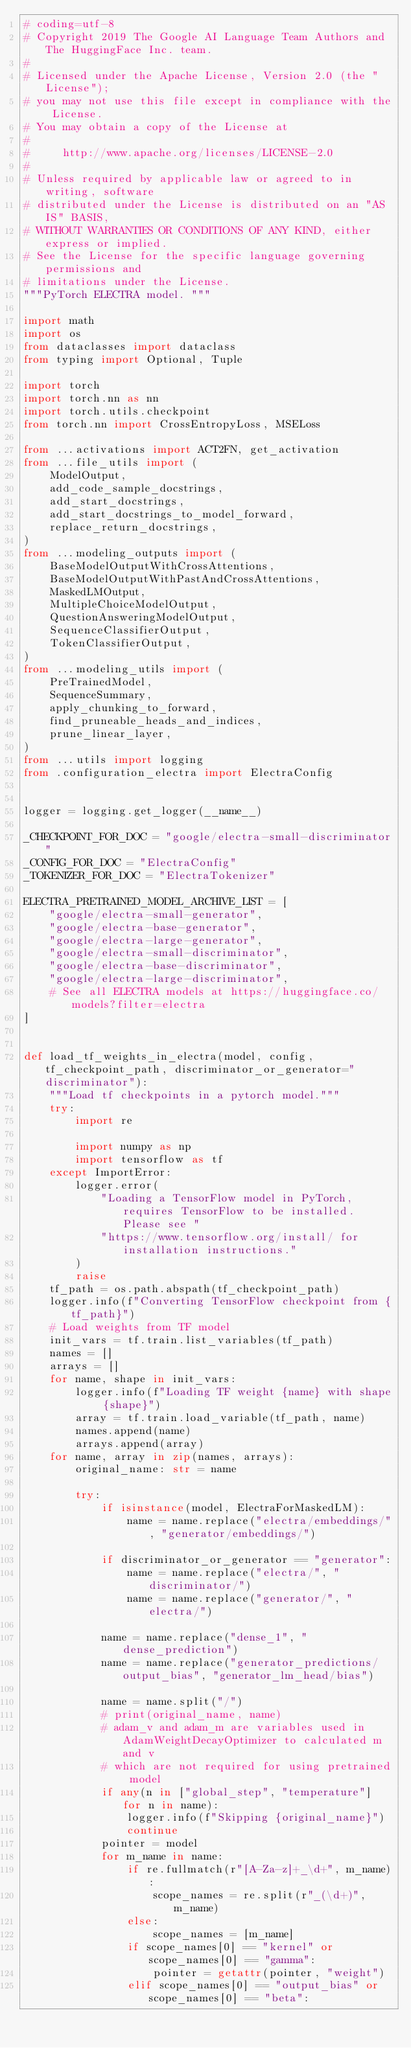Convert code to text. <code><loc_0><loc_0><loc_500><loc_500><_Python_># coding=utf-8
# Copyright 2019 The Google AI Language Team Authors and The HuggingFace Inc. team.
#
# Licensed under the Apache License, Version 2.0 (the "License");
# you may not use this file except in compliance with the License.
# You may obtain a copy of the License at
#
#     http://www.apache.org/licenses/LICENSE-2.0
#
# Unless required by applicable law or agreed to in writing, software
# distributed under the License is distributed on an "AS IS" BASIS,
# WITHOUT WARRANTIES OR CONDITIONS OF ANY KIND, either express or implied.
# See the License for the specific language governing permissions and
# limitations under the License.
"""PyTorch ELECTRA model. """

import math
import os
from dataclasses import dataclass
from typing import Optional, Tuple

import torch
import torch.nn as nn
import torch.utils.checkpoint
from torch.nn import CrossEntropyLoss, MSELoss

from ...activations import ACT2FN, get_activation
from ...file_utils import (
    ModelOutput,
    add_code_sample_docstrings,
    add_start_docstrings,
    add_start_docstrings_to_model_forward,
    replace_return_docstrings,
)
from ...modeling_outputs import (
    BaseModelOutputWithCrossAttentions,
    BaseModelOutputWithPastAndCrossAttentions,
    MaskedLMOutput,
    MultipleChoiceModelOutput,
    QuestionAnsweringModelOutput,
    SequenceClassifierOutput,
    TokenClassifierOutput,
)
from ...modeling_utils import (
    PreTrainedModel,
    SequenceSummary,
    apply_chunking_to_forward,
    find_pruneable_heads_and_indices,
    prune_linear_layer,
)
from ...utils import logging
from .configuration_electra import ElectraConfig


logger = logging.get_logger(__name__)

_CHECKPOINT_FOR_DOC = "google/electra-small-discriminator"
_CONFIG_FOR_DOC = "ElectraConfig"
_TOKENIZER_FOR_DOC = "ElectraTokenizer"

ELECTRA_PRETRAINED_MODEL_ARCHIVE_LIST = [
    "google/electra-small-generator",
    "google/electra-base-generator",
    "google/electra-large-generator",
    "google/electra-small-discriminator",
    "google/electra-base-discriminator",
    "google/electra-large-discriminator",
    # See all ELECTRA models at https://huggingface.co/models?filter=electra
]


def load_tf_weights_in_electra(model, config, tf_checkpoint_path, discriminator_or_generator="discriminator"):
    """Load tf checkpoints in a pytorch model."""
    try:
        import re

        import numpy as np
        import tensorflow as tf
    except ImportError:
        logger.error(
            "Loading a TensorFlow model in PyTorch, requires TensorFlow to be installed. Please see "
            "https://www.tensorflow.org/install/ for installation instructions."
        )
        raise
    tf_path = os.path.abspath(tf_checkpoint_path)
    logger.info(f"Converting TensorFlow checkpoint from {tf_path}")
    # Load weights from TF model
    init_vars = tf.train.list_variables(tf_path)
    names = []
    arrays = []
    for name, shape in init_vars:
        logger.info(f"Loading TF weight {name} with shape {shape}")
        array = tf.train.load_variable(tf_path, name)
        names.append(name)
        arrays.append(array)
    for name, array in zip(names, arrays):
        original_name: str = name

        try:
            if isinstance(model, ElectraForMaskedLM):
                name = name.replace("electra/embeddings/", "generator/embeddings/")

            if discriminator_or_generator == "generator":
                name = name.replace("electra/", "discriminator/")
                name = name.replace("generator/", "electra/")

            name = name.replace("dense_1", "dense_prediction")
            name = name.replace("generator_predictions/output_bias", "generator_lm_head/bias")

            name = name.split("/")
            # print(original_name, name)
            # adam_v and adam_m are variables used in AdamWeightDecayOptimizer to calculated m and v
            # which are not required for using pretrained model
            if any(n in ["global_step", "temperature"] for n in name):
                logger.info(f"Skipping {original_name}")
                continue
            pointer = model
            for m_name in name:
                if re.fullmatch(r"[A-Za-z]+_\d+", m_name):
                    scope_names = re.split(r"_(\d+)", m_name)
                else:
                    scope_names = [m_name]
                if scope_names[0] == "kernel" or scope_names[0] == "gamma":
                    pointer = getattr(pointer, "weight")
                elif scope_names[0] == "output_bias" or scope_names[0] == "beta":</code> 